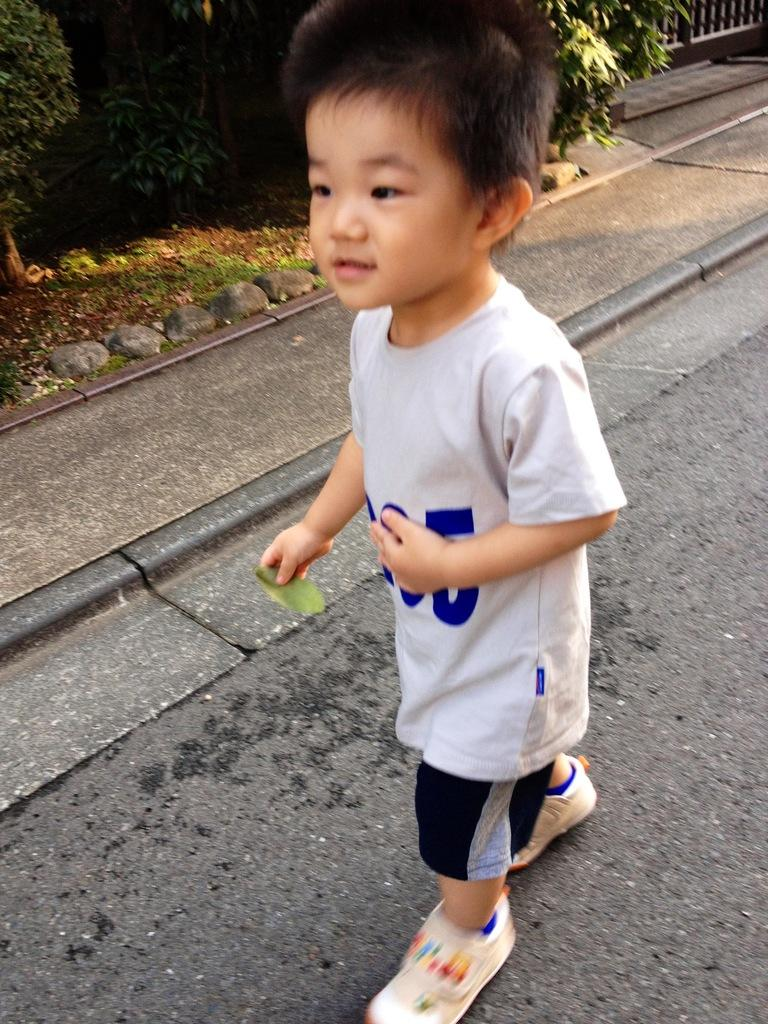Who is the main subject in the image? There is a boy in the image. What is the boy doing in the image? The boy is standing on the road. What can be seen in the background of the image? There are plants and rocks in the background of the image. How does the boy use the sink in the image? There is no sink present in the image. What type of stick can be seen in the boy's hand in the image? There is no stick present in the boy's hand in the image. 